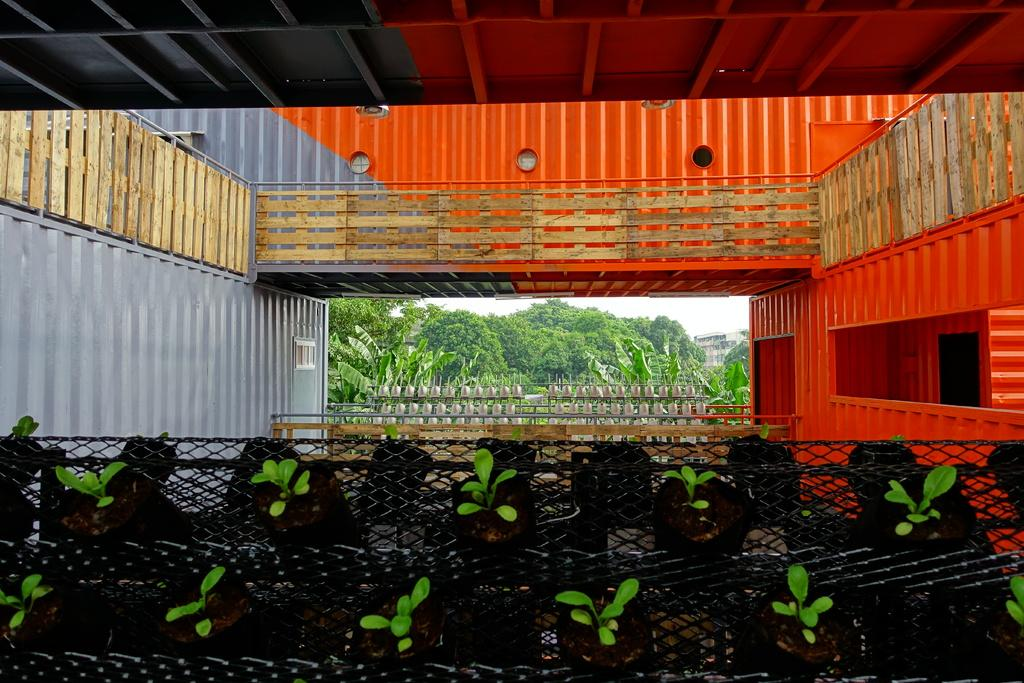What type of structure can be seen in the image? There is a shed in the image. What feature is present near the shed? There are railings in the image. What natural elements are visible in the image? There are trees and plants in the image. What type of man-made structures can be seen in the image? There are buildings in the image. What material is present in the image that has a mesh-like appearance? There is a mesh in the image. Where is the loaf of bread located in the image? There is no loaf of bread present in the image. What type of map can be seen in the image? There is no map present in the image. 